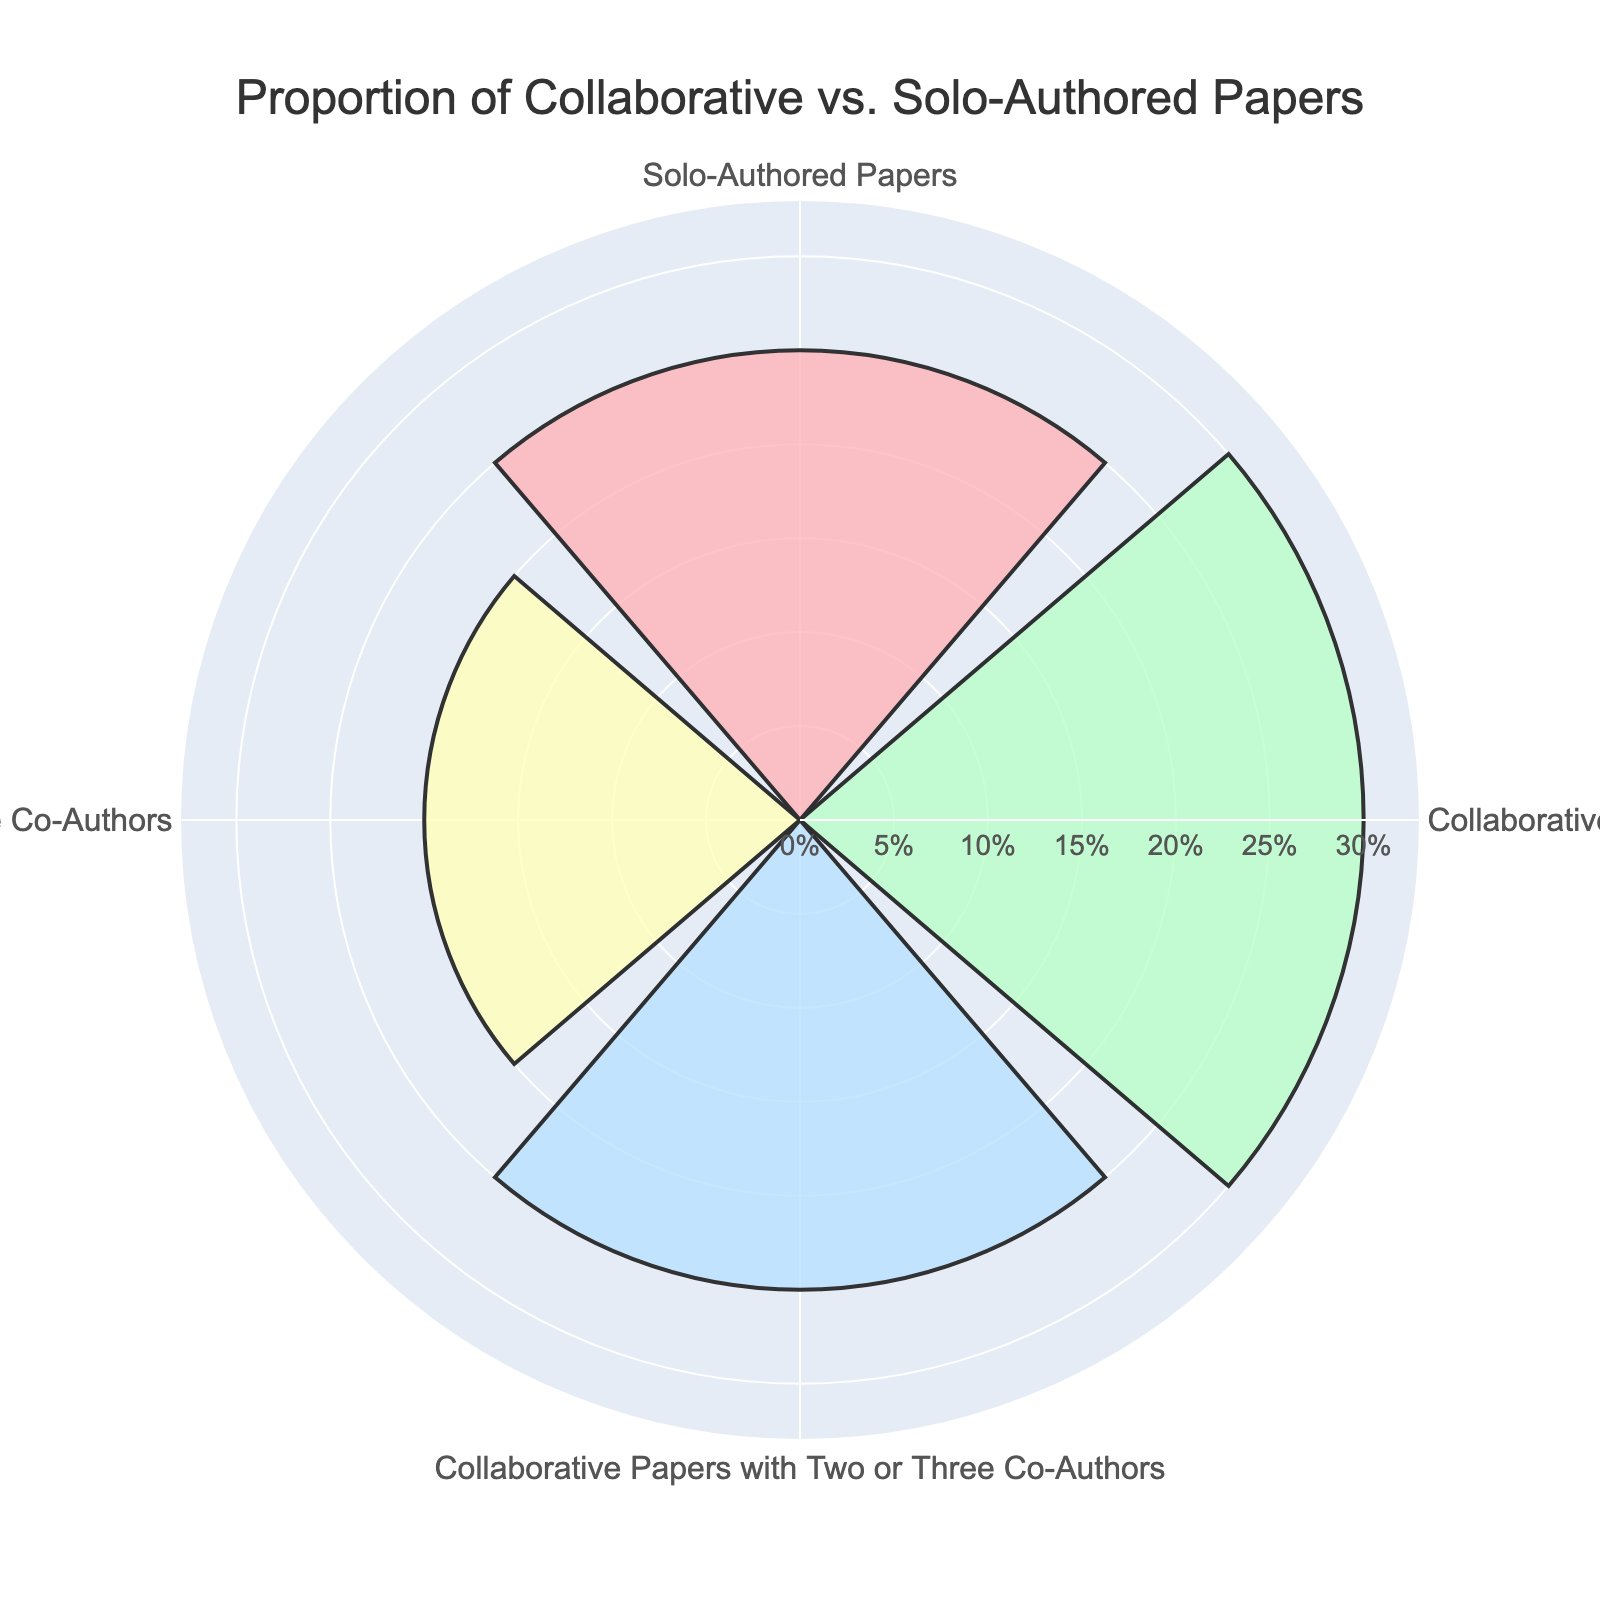What is the title of the figure? The title is usually the text placed prominently at the top of the figure, providing a clear indication of what the figure represents. In this figure, the title is, "Proportion of Collaborative vs. Solo-Authored Papers".
Answer: Proportion of Collaborative vs. Solo-Authored Papers Which type of paper has the highest proportion? By examining the lengths of the radial bars, we see that the bar corresponding to "Collaborative Papers with One Co-Author" is the longest, representing the highest proportion.
Answer: Collaborative Papers with One Co-Author What proportion of the professor's papers are solo-authored? Look at the radial bar labeled "Solo-Authored Papers". The proportion next to this label is 25%.
Answer: 25% How does the proportion of solo-authored papers compare to collaborative papers with more than three co-authors? Compare the lengths of the radial bars for "Solo-Authored Papers" and "Collaborative Papers with More Than Three Co-Authors". The solo-authored papers have a proportion of 25%, while collaborative papers with more than three co-authors have a proportion of 20%. Therefore, the proportion of solo-authored papers is greater.
Answer: Solo-authored papers: 25%; Collaborative papers with more than three co-authors: 20% Sum up the proportions of all collaborative papers. There are three collaborative categories: "Collaborative Papers with One Co-Author" (30%), "Collaborative Papers with Two or Three Co-Authors" (25%), and "Collaborative Papers with More Than Three Co-Authors" (20%). Adding these gives us 30% + 25% + 20% = 75%.
Answer: 75% What is the average proportion of the collaborative paper categories? There are three collaborative categories: "Collaborative Papers with One Co-Author" (30%), "Collaborative Papers with Two or Three Co-Authors" (25%), and "Collaborative Papers with More Than Three Co-Authors" (20%). The average is calculated by summing these values and dividing by the number of categories: (30% + 25% + 20%) / 3 ≈ 25%.
Answer: 25% Which categories have the same proportion of papers? By visually comparing the radial bars, we see that the "Solo-Authored Papers" and "Collaborative Papers with Two or Three Co-Authors" both have a proportion of 25%.
Answer: Solo-Authored Papers and Collaborative Papers with Two or Three Co-Authors Is the proportion of collaborative papers with one co-author greater than the proportion of all solo-authored papers combined? Compare the proportions: "Collaborative Papers with One Co-Author" has 30%, and "Solo-Authored Papers" has 25%. Therefore, the proportion of collaborative papers with one co-author is indeed greater.
Answer: Yes 